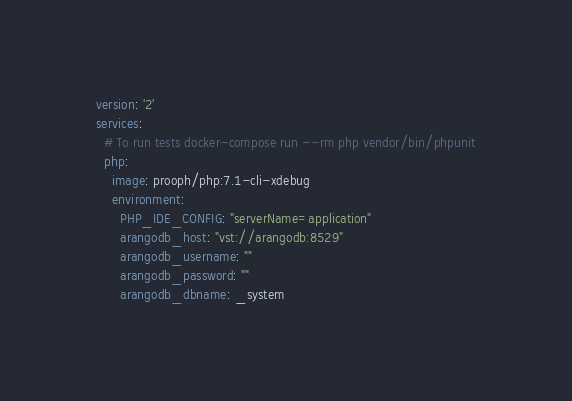Convert code to text. <code><loc_0><loc_0><loc_500><loc_500><_YAML_>version: '2'
services:
  # To run tests docker-compose run --rm php vendor/bin/phpunit
  php:
    image: prooph/php:7.1-cli-xdebug
    environment:
      PHP_IDE_CONFIG: "serverName=application"
      arangodb_host: "vst://arangodb:8529"
      arangodb_username: ""
      arangodb_password: ""
      arangodb_dbname: _system</code> 